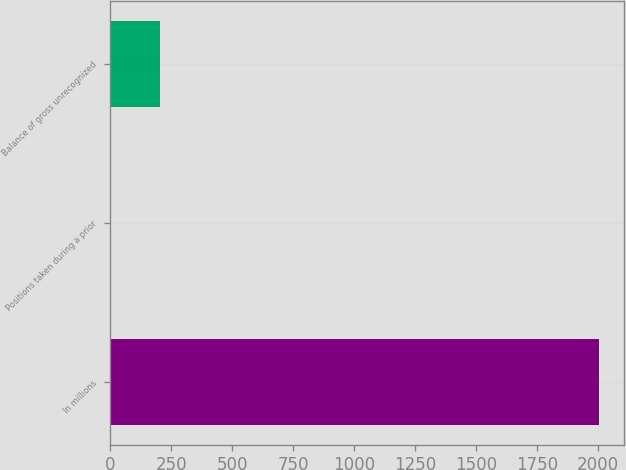Convert chart to OTSL. <chart><loc_0><loc_0><loc_500><loc_500><bar_chart><fcel>In millions<fcel>Positions taken during a prior<fcel>Balance of gross unrecognized<nl><fcel>2007<fcel>2<fcel>202.5<nl></chart> 